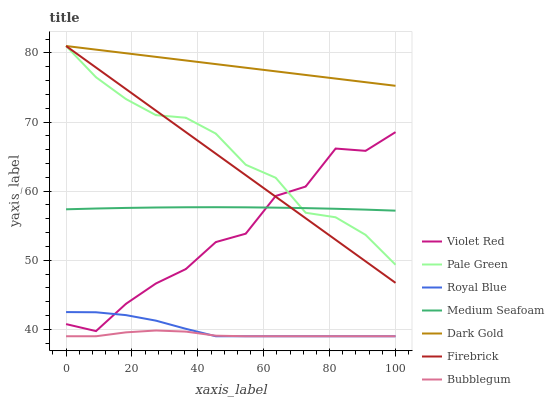Does Bubblegum have the minimum area under the curve?
Answer yes or no. Yes. Does Dark Gold have the maximum area under the curve?
Answer yes or no. Yes. Does Firebrick have the minimum area under the curve?
Answer yes or no. No. Does Firebrick have the maximum area under the curve?
Answer yes or no. No. Is Firebrick the smoothest?
Answer yes or no. Yes. Is Violet Red the roughest?
Answer yes or no. Yes. Is Dark Gold the smoothest?
Answer yes or no. No. Is Dark Gold the roughest?
Answer yes or no. No. Does Bubblegum have the lowest value?
Answer yes or no. Yes. Does Firebrick have the lowest value?
Answer yes or no. No. Does Pale Green have the highest value?
Answer yes or no. Yes. Does Bubblegum have the highest value?
Answer yes or no. No. Is Royal Blue less than Medium Seafoam?
Answer yes or no. Yes. Is Firebrick greater than Royal Blue?
Answer yes or no. Yes. Does Bubblegum intersect Royal Blue?
Answer yes or no. Yes. Is Bubblegum less than Royal Blue?
Answer yes or no. No. Is Bubblegum greater than Royal Blue?
Answer yes or no. No. Does Royal Blue intersect Medium Seafoam?
Answer yes or no. No. 